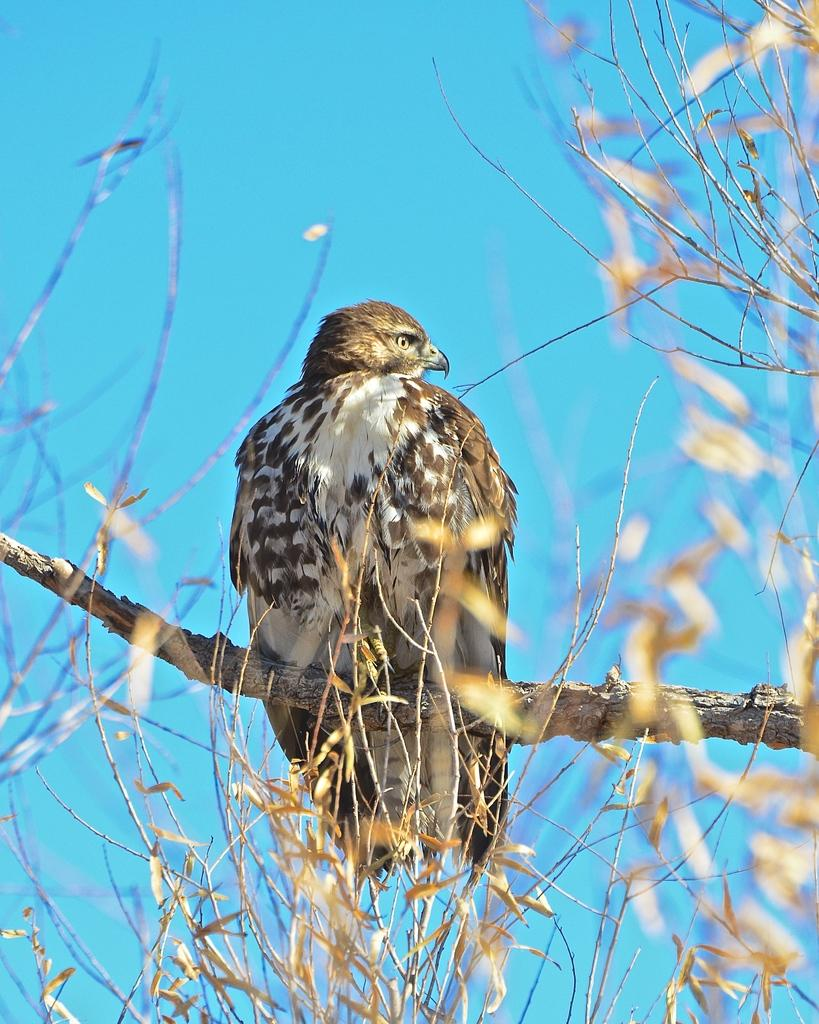What type of animal can be seen in the image? There is a bird in the image. Where is the bird located? The bird is on a tree. What can be seen in the background of the image? There is a sky visible in the background of the image. What type of guitar is the bird playing in the image? There is no guitar present in the image; it features a bird on a tree with a visible sky in the background. 